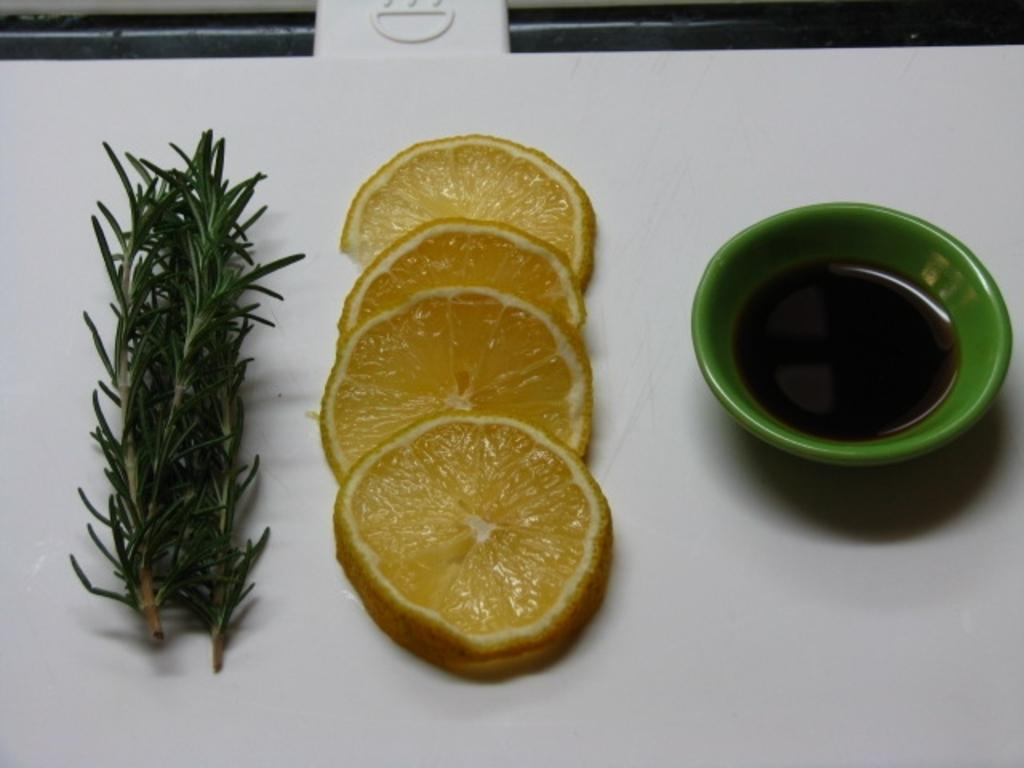What type of furniture is in the image? There is a table in the image. What can be seen on the table? Lemon slices and a plant are present on the table. What might be used for holding a beverage in the image? There is a cup with liquid in the image. What type of laborer is working on the plant in the image? There is no laborer present in the image, and the plant does not appear to be receiving any care or attention. 